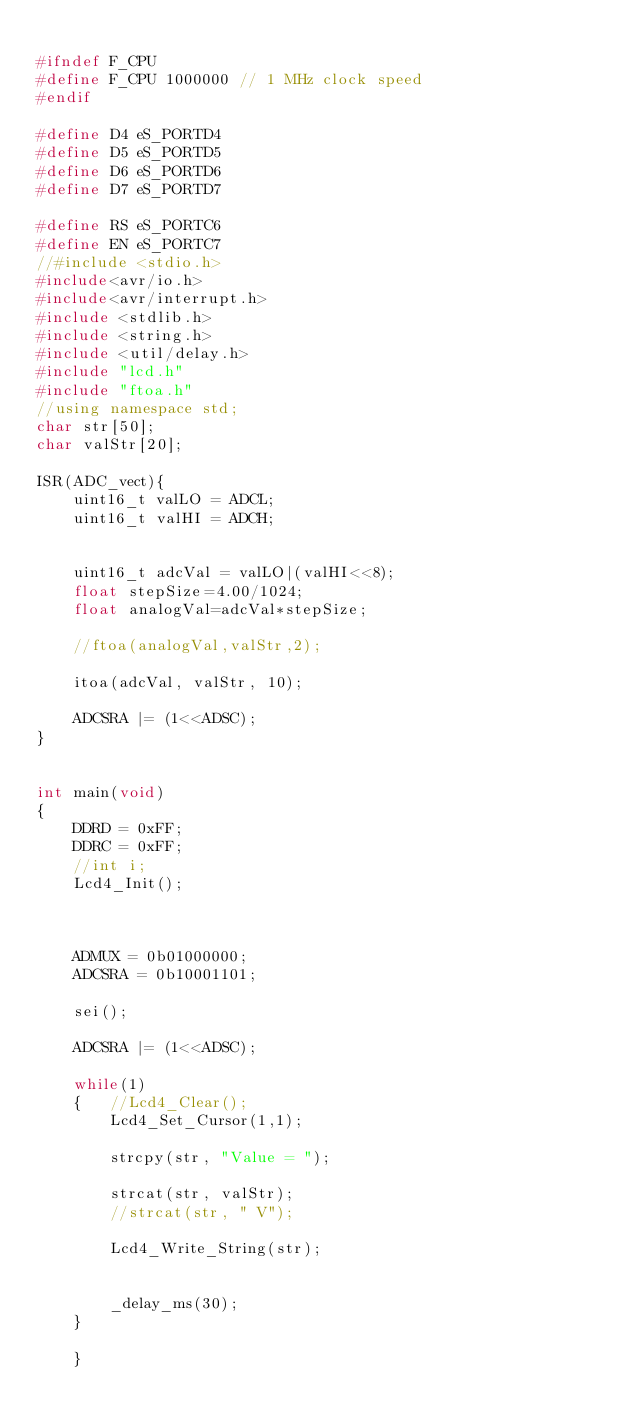<code> <loc_0><loc_0><loc_500><loc_500><_C_>
#ifndef F_CPU
#define F_CPU 1000000 // 1 MHz clock speed
#endif

#define D4 eS_PORTD4
#define D5 eS_PORTD5
#define D6 eS_PORTD6
#define D7 eS_PORTD7

#define RS eS_PORTC6
#define EN eS_PORTC7
//#include <stdio.h>
#include<avr/io.h>
#include<avr/interrupt.h>
#include <stdlib.h>
#include <string.h>
#include <util/delay.h>
#include "lcd.h"
#include "ftoa.h"
//using namespace std;
char str[50];
char valStr[20];

ISR(ADC_vect){
	uint16_t valLO = ADCL;
	uint16_t valHI = ADCH;

	
	uint16_t adcVal = valLO|(valHI<<8);
	float stepSize=4.00/1024;
	float analogVal=adcVal*stepSize;
	
	//ftoa(analogVal,valStr,2);

	itoa(adcVal, valStr, 10);

	ADCSRA |= (1<<ADSC);
}


int main(void)
{
    DDRD = 0xFF;
	DDRC = 0xFF;
	//int i;
	Lcd4_Init();
	


	ADMUX = 0b01000000;
	ADCSRA = 0b10001101;

	sei();

	ADCSRA |= (1<<ADSC);
	
	while(1)
	{	//Lcd4_Clear();
		Lcd4_Set_Cursor(1,1);
		
		strcpy(str, "Value = ");
	
		strcat(str, valStr);
		//strcat(str, " V");

		Lcd4_Write_String(str);
		
		
		_delay_ms(30);
	}

	}
</code> 